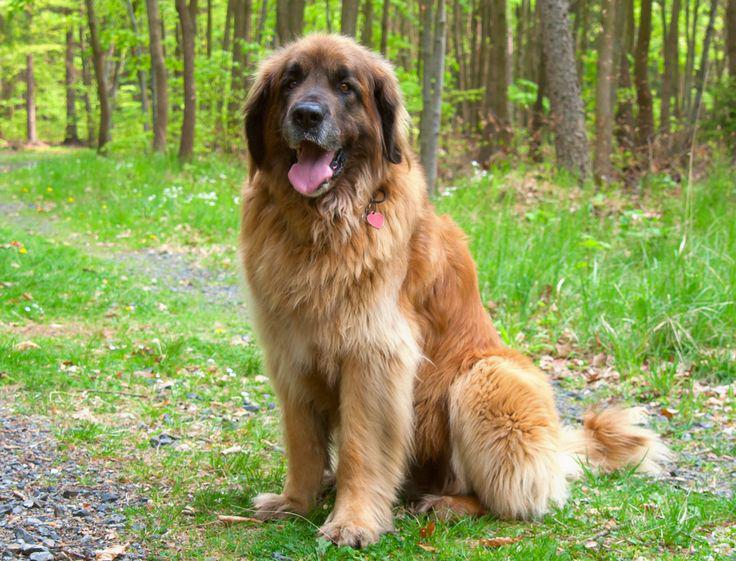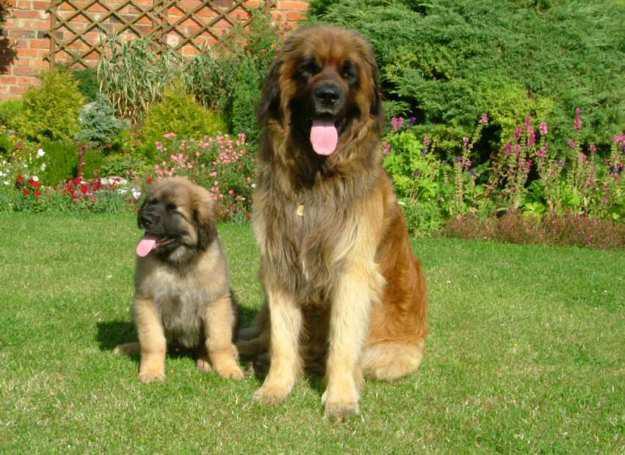The first image is the image on the left, the second image is the image on the right. Assess this claim about the two images: "There are a total of two dogs standing on all four legs.". Correct or not? Answer yes or no. No. 